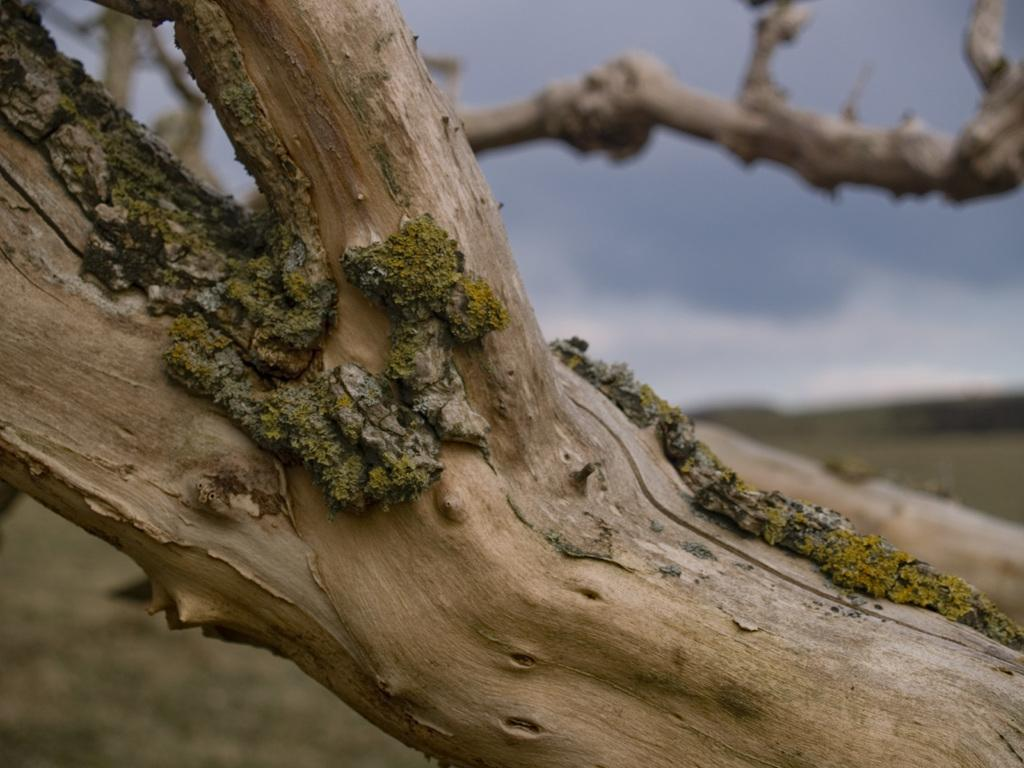What is the main subject in the center of the image? There is a stem in the center of the image. Can you describe the background of the image? The background of the image is blurry. How many eggs does the hen lay in a week in the image? There is no hen or eggs present in the image, so this question cannot be answered. 